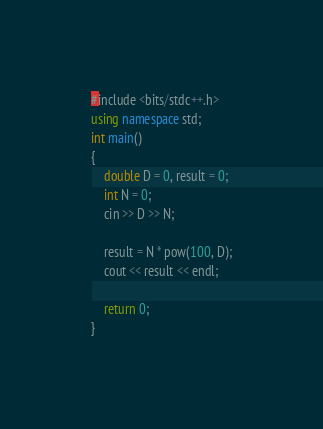<code> <loc_0><loc_0><loc_500><loc_500><_C#_>#include <bits/stdc++.h>
using namespace std;
int main()
{
    double D = 0, result = 0;
    int N = 0;
    cin >> D >> N;

    result = N * pow(100, D);
    cout << result << endl;

    return 0;
}</code> 